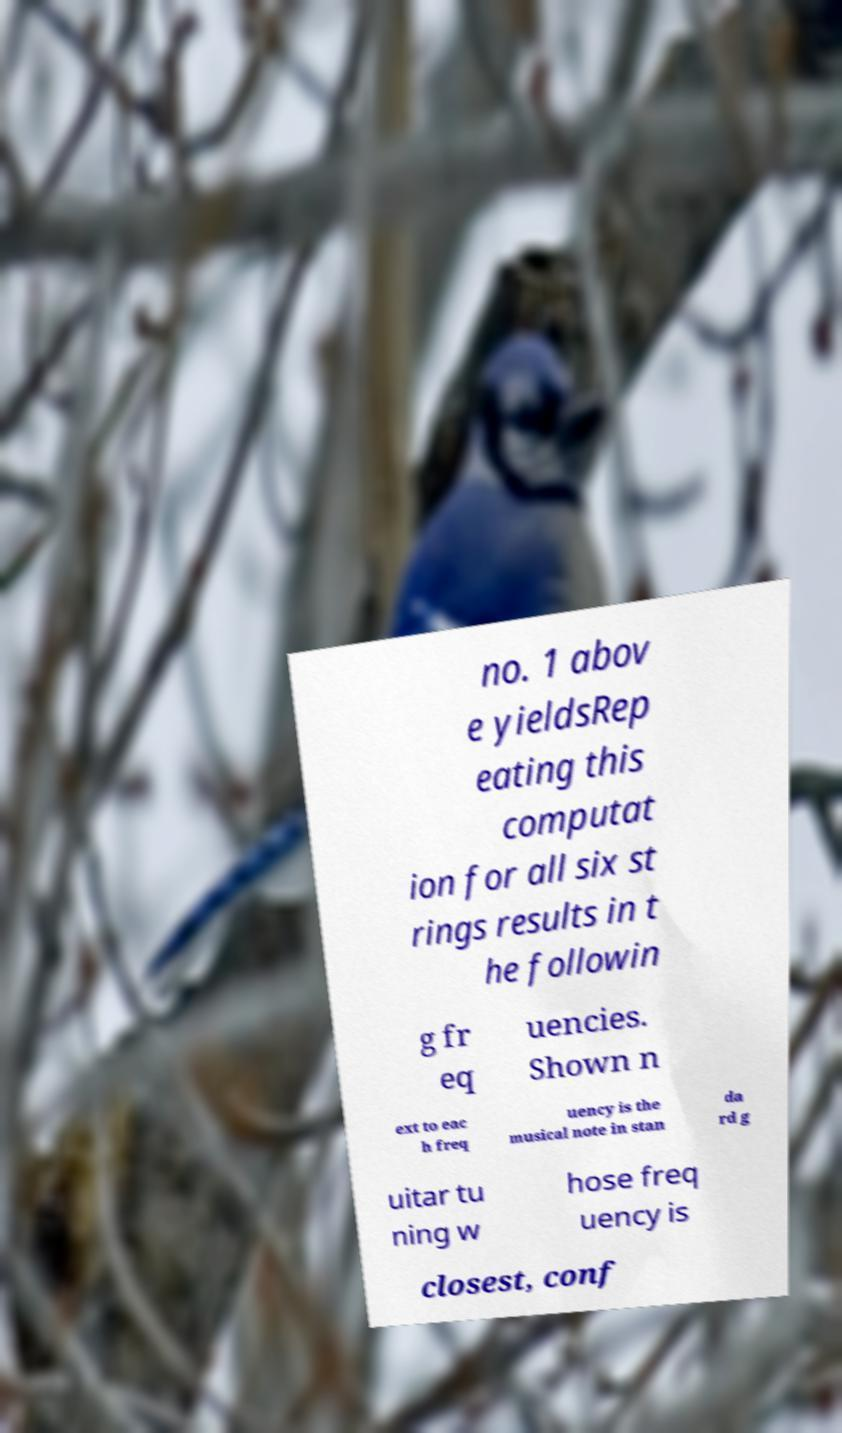Can you read and provide the text displayed in the image?This photo seems to have some interesting text. Can you extract and type it out for me? no. 1 abov e yieldsRep eating this computat ion for all six st rings results in t he followin g fr eq uencies. Shown n ext to eac h freq uency is the musical note in stan da rd g uitar tu ning w hose freq uency is closest, conf 